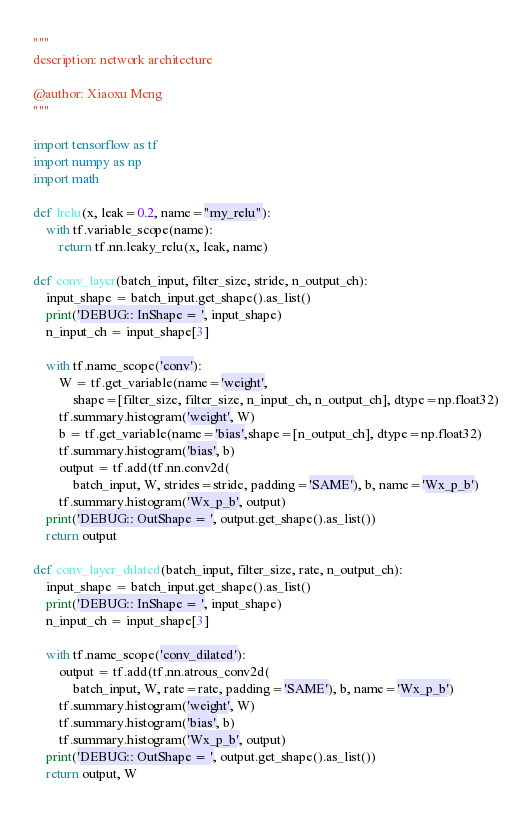Convert code to text. <code><loc_0><loc_0><loc_500><loc_500><_Python_>"""
description: network architecture

@author: Xiaoxu Meng
"""

import tensorflow as tf
import numpy as np
import math

def lrelu(x, leak=0.2, name="my_relu"):
    with tf.variable_scope(name):
        return tf.nn.leaky_relu(x, leak, name)

def conv_layer(batch_input, filter_size, stride, n_output_ch):
    input_shape = batch_input.get_shape().as_list()
    print('DEBUG:: InShape = ', input_shape)
    n_input_ch = input_shape[3]
    
    with tf.name_scope('conv'):
        W = tf.get_variable(name='weight',
            shape=[filter_size, filter_size, n_input_ch, n_output_ch], dtype=np.float32)
        tf.summary.histogram('weight', W)
        b = tf.get_variable(name='bias',shape=[n_output_ch], dtype=np.float32)
        tf.summary.histogram('bias', b)
        output = tf.add(tf.nn.conv2d(
            batch_input, W, strides=stride, padding='SAME'), b, name='Wx_p_b')
        tf.summary.histogram('Wx_p_b', output)
    print('DEBUG:: OutShape = ', output.get_shape().as_list())
    return output

def conv_layer_dilated(batch_input, filter_size, rate, n_output_ch):
    input_shape = batch_input.get_shape().as_list()
    print('DEBUG:: InShape = ', input_shape)
    n_input_ch = input_shape[3]

    with tf.name_scope('conv_dilated'):
        output = tf.add(tf.nn.atrous_conv2d(
            batch_input, W, rate=rate, padding='SAME'), b, name='Wx_p_b')
        tf.summary.histogram('weight', W)
        tf.summary.histogram('bias', b)
        tf.summary.histogram('Wx_p_b', output)
    print('DEBUG:: OutShape = ', output.get_shape().as_list())
    return output, W
</code> 